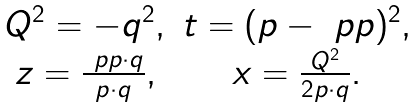<formula> <loc_0><loc_0><loc_500><loc_500>\begin{array} { c c } Q ^ { 2 } = - q ^ { 2 } , & t = ( p - \ p p ) ^ { 2 } , \\ z = \frac { \ p p \cdot q } { p \cdot q } , & x = \frac { Q ^ { 2 } } { 2 p \cdot q } . \end{array}</formula> 